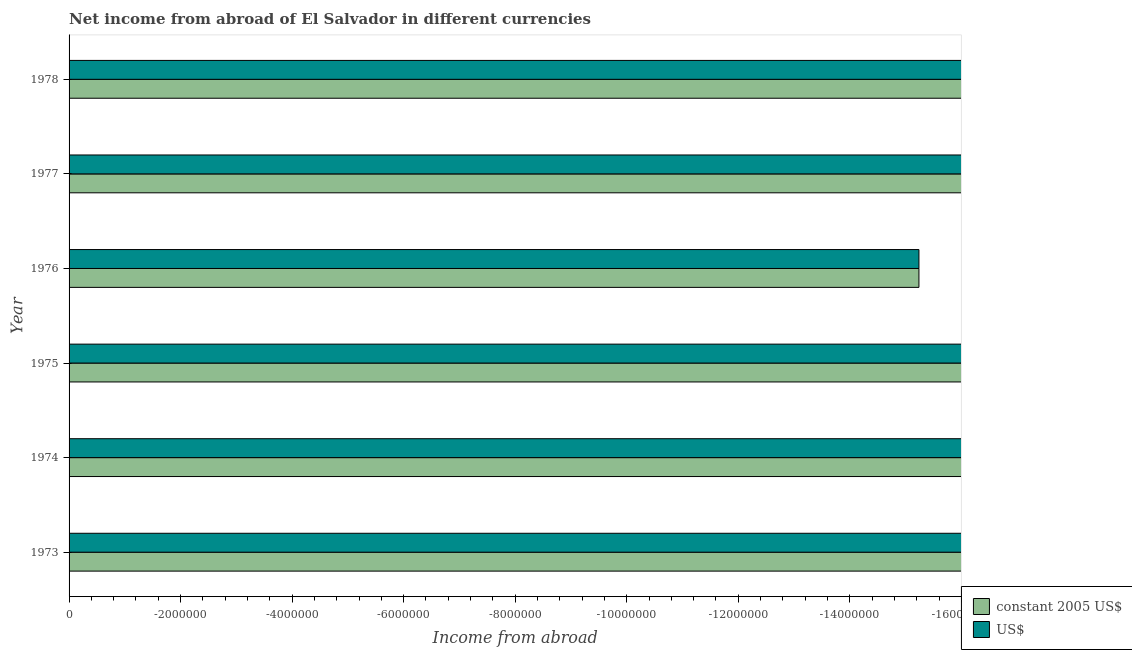Are the number of bars on each tick of the Y-axis equal?
Ensure brevity in your answer.  Yes. How many bars are there on the 5th tick from the top?
Your response must be concise. 0. How many bars are there on the 2nd tick from the bottom?
Offer a terse response. 0. What is the label of the 1st group of bars from the top?
Provide a short and direct response. 1978. What is the income from abroad in us$ in 1975?
Your answer should be compact. 0. Across all years, what is the minimum income from abroad in constant 2005 us$?
Give a very brief answer. 0. In how many years, is the income from abroad in constant 2005 us$ greater than the average income from abroad in constant 2005 us$ taken over all years?
Keep it short and to the point. 0. Are all the bars in the graph horizontal?
Your response must be concise. Yes. How many years are there in the graph?
Make the answer very short. 6. What is the difference between two consecutive major ticks on the X-axis?
Your answer should be very brief. 2.00e+06. Are the values on the major ticks of X-axis written in scientific E-notation?
Make the answer very short. No. Does the graph contain any zero values?
Your answer should be very brief. Yes. Does the graph contain grids?
Offer a very short reply. No. Where does the legend appear in the graph?
Keep it short and to the point. Bottom right. How many legend labels are there?
Keep it short and to the point. 2. What is the title of the graph?
Provide a succinct answer. Net income from abroad of El Salvador in different currencies. Does "Short-term debt" appear as one of the legend labels in the graph?
Your answer should be compact. No. What is the label or title of the X-axis?
Give a very brief answer. Income from abroad. What is the Income from abroad in US$ in 1973?
Make the answer very short. 0. What is the Income from abroad in US$ in 1974?
Provide a short and direct response. 0. What is the Income from abroad in constant 2005 US$ in 1975?
Give a very brief answer. 0. What is the Income from abroad of US$ in 1975?
Provide a succinct answer. 0. What is the Income from abroad in constant 2005 US$ in 1976?
Your response must be concise. 0. What is the Income from abroad in constant 2005 US$ in 1977?
Provide a succinct answer. 0. What is the Income from abroad in US$ in 1977?
Keep it short and to the point. 0. What is the Income from abroad in constant 2005 US$ in 1978?
Ensure brevity in your answer.  0. What is the total Income from abroad of constant 2005 US$ in the graph?
Offer a terse response. 0. What is the total Income from abroad of US$ in the graph?
Your answer should be compact. 0. What is the average Income from abroad of US$ per year?
Offer a terse response. 0. 